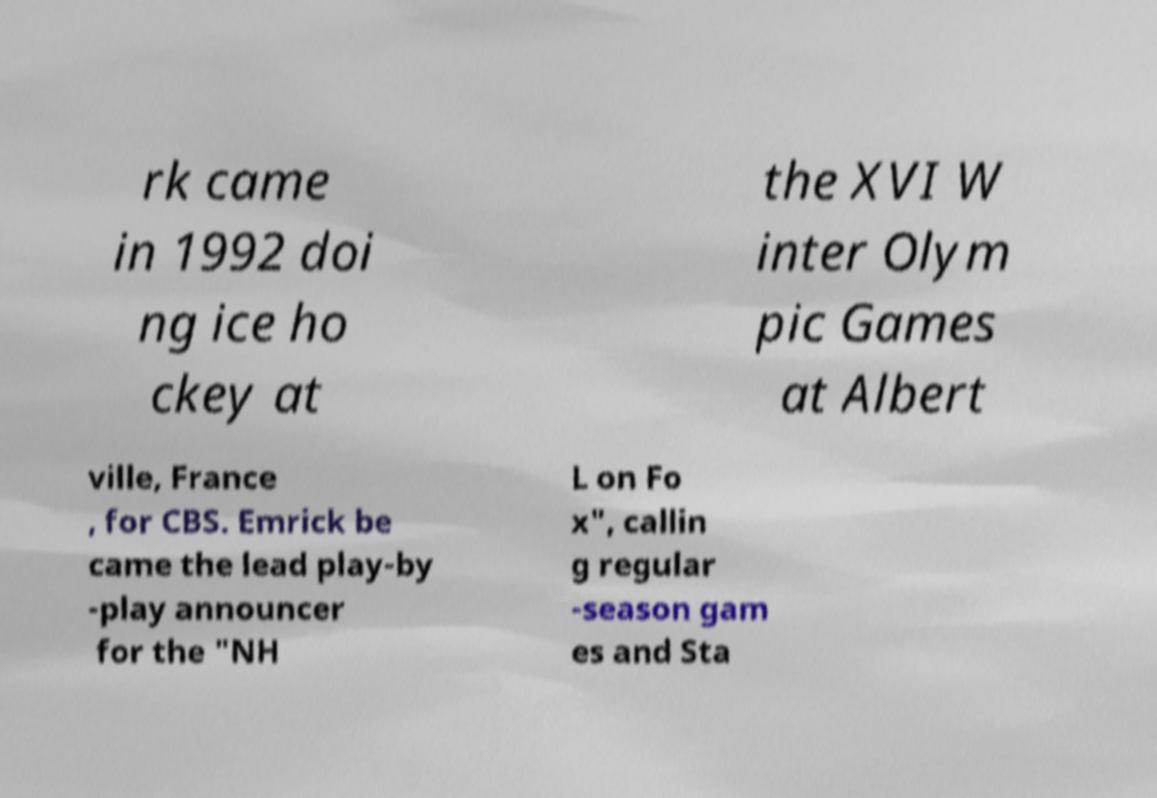For documentation purposes, I need the text within this image transcribed. Could you provide that? rk came in 1992 doi ng ice ho ckey at the XVI W inter Olym pic Games at Albert ville, France , for CBS. Emrick be came the lead play-by -play announcer for the "NH L on Fo x", callin g regular -season gam es and Sta 